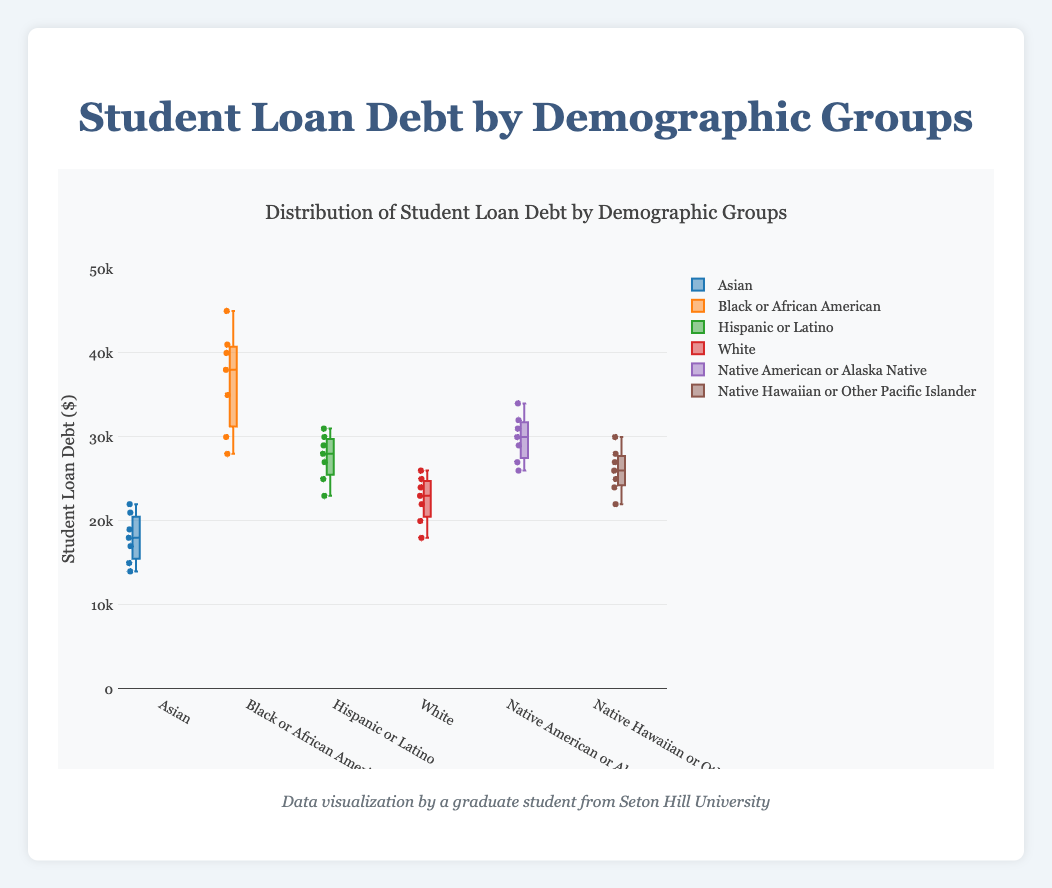What is the title of the figure? The title is usually placed at the top to summarize what the figure represents. In this case, the title is explicitly shown in the code provided.
Answer: Student Loan Debt by Demographic Groups What is the range of the y-axis? The y-axis range is explicitly defined in the layout settings of the plot, indicating the span of student loan debt values covered on the plot.
Answer: 0 to 50000 How many demographic groups are compared in the figure? By counting the number of distinct groups in the dataset or by looking at the legend in the plot, we can determine the number of demographic groups. There are six groups provided.
Answer: 6 Which demographic group has the highest median student loan debt? To find the group with the highest median, locate the middle line in each box plot and note which one is the highest.
Answer: Black or African American What is the interquartile range (IQR) for the Hispanic or Latino group? The IQR is the range between the first quartile (Q1) and the third quartile (Q3). Identify these bounds on the box plot for the Hispanic or Latino group and subtract Q1 from Q3.
Answer: 8000 (from 23000 to 31000) Which group has the smallest range of student loan debt values? The range is calculated as the difference between the minimum and maximum values. The group with the smallest range has the shortest whiskers on the box plot.
Answer: Asian Is there any demographic group with an outlier? If so, which group? An outlier is denoted by individual data points outside the whiskers of the box plot. Look for dots outside the whiskers in any of the box plots.
Answer: Black or African American Compare the median student loan debt of White students to Native American or Alaska Native students. To compare, locate and compare the median lines in the box plots of the two groups. The White group's median line is lower than the Native American or Alaska Native group's median line.
Answer: The median debt for Native American or Alaska Native students is higher What is the second-highest median student loan debt among the groups? Identify the median line for each group and rank them; the second-highest is just below the highest one.
Answer: Native American or Alaska Native For the Native Hawaiian or Other Pacific Islander group, what is the difference between the highest data point and the median? Identify the highest point within the whiskers and subtract the median value of the box plot for this group.
Answer: 5000 (from 30000 to 25000) 